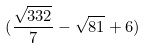<formula> <loc_0><loc_0><loc_500><loc_500>( \frac { \sqrt { 3 3 2 } } { 7 } - \sqrt { 8 1 } + 6 )</formula> 